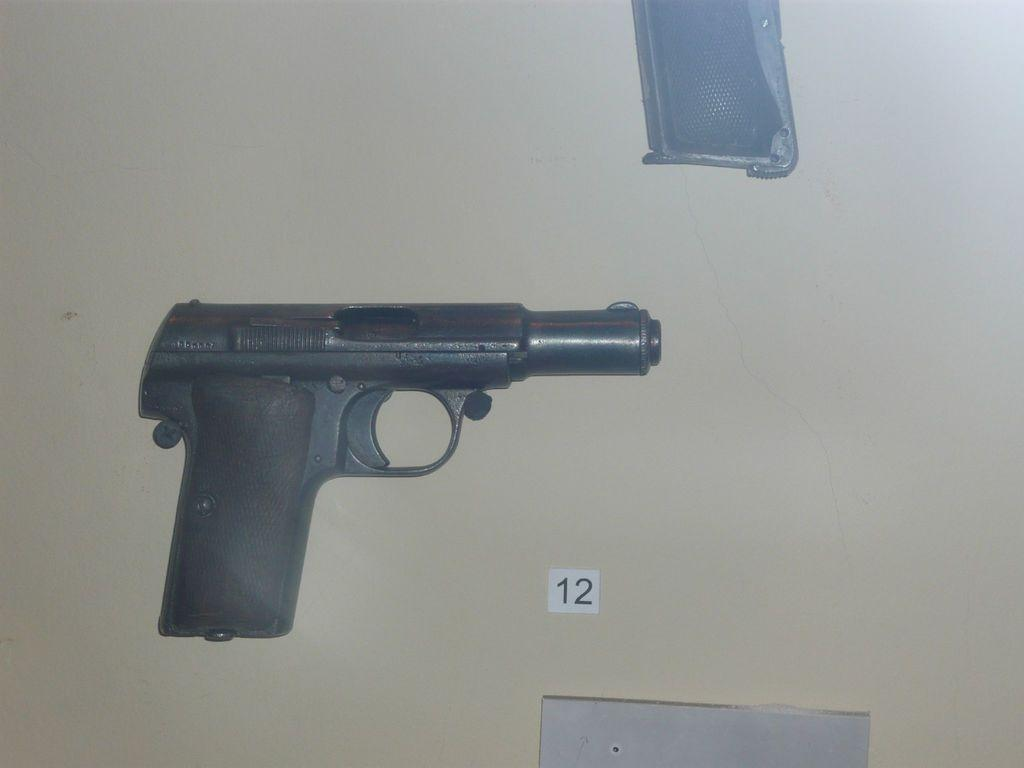What object is the main focus of the image? There is a revolver in the image. Where is the revolver located? The revolver is on a table. Is there any text or numbers visible in the image? Yes, there is a slip of paper with the number "12" written on it in the image. What part of the revolver can be used to hold and operate it? The revolver has a handle. What type of meal is being prepared on the table in the image? There is no meal preparation visible in the image; it features a revolver on a table. What role does the minister play in the image? There is no minister present in the image. 